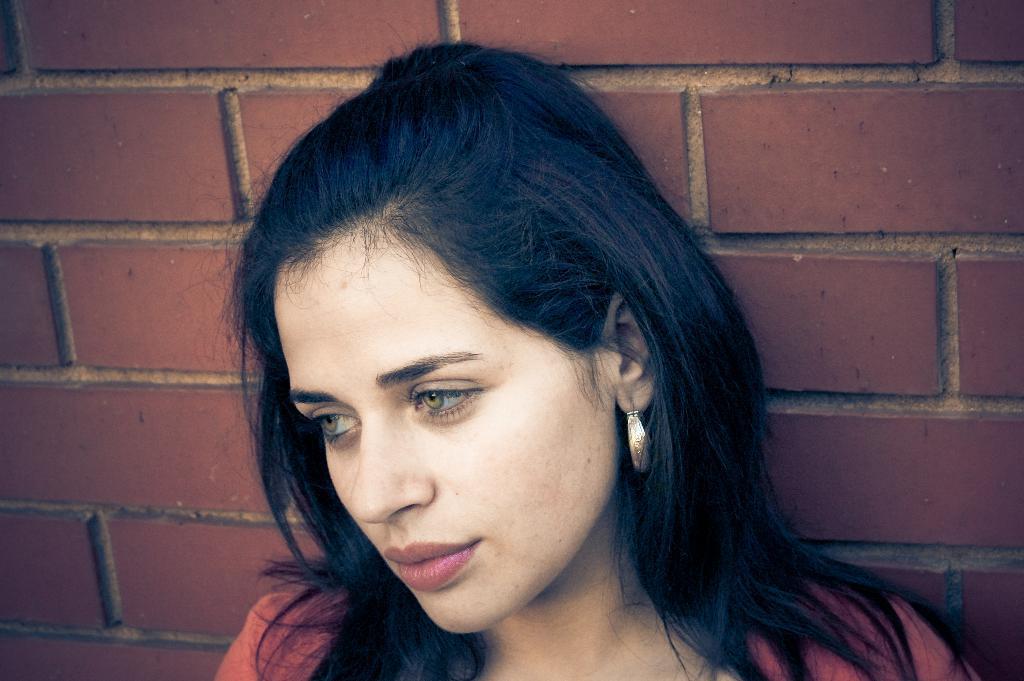Describe this image in one or two sentences. Here we can see a woman. In the background there is a wall. 